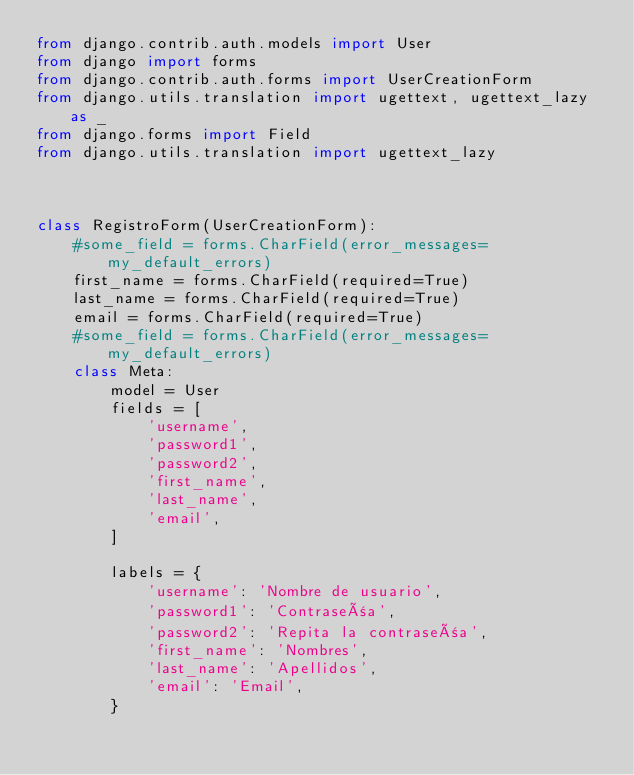<code> <loc_0><loc_0><loc_500><loc_500><_Python_>from django.contrib.auth.models import User
from django import forms
from django.contrib.auth.forms import UserCreationForm
from django.utils.translation import ugettext, ugettext_lazy as _
from django.forms import Field
from django.utils.translation import ugettext_lazy



class RegistroForm(UserCreationForm):
    #some_field = forms.CharField(error_messages=my_default_errors)
    first_name = forms.CharField(required=True)
    last_name = forms.CharField(required=True)
    email = forms.CharField(required=True)
    #some_field = forms.CharField(error_messages=my_default_errors)
    class Meta:
        model = User
        fields = [
            'username',
            'password1',
            'password2',
            'first_name',
            'last_name',
            'email',
        ]

        labels = {
            'username': 'Nombre de usuario',
            'password1': 'Contraseña',
            'password2': 'Repita la contraseña',
            'first_name': 'Nombres',
            'last_name': 'Apellidos',
            'email': 'Email',
        }
</code> 